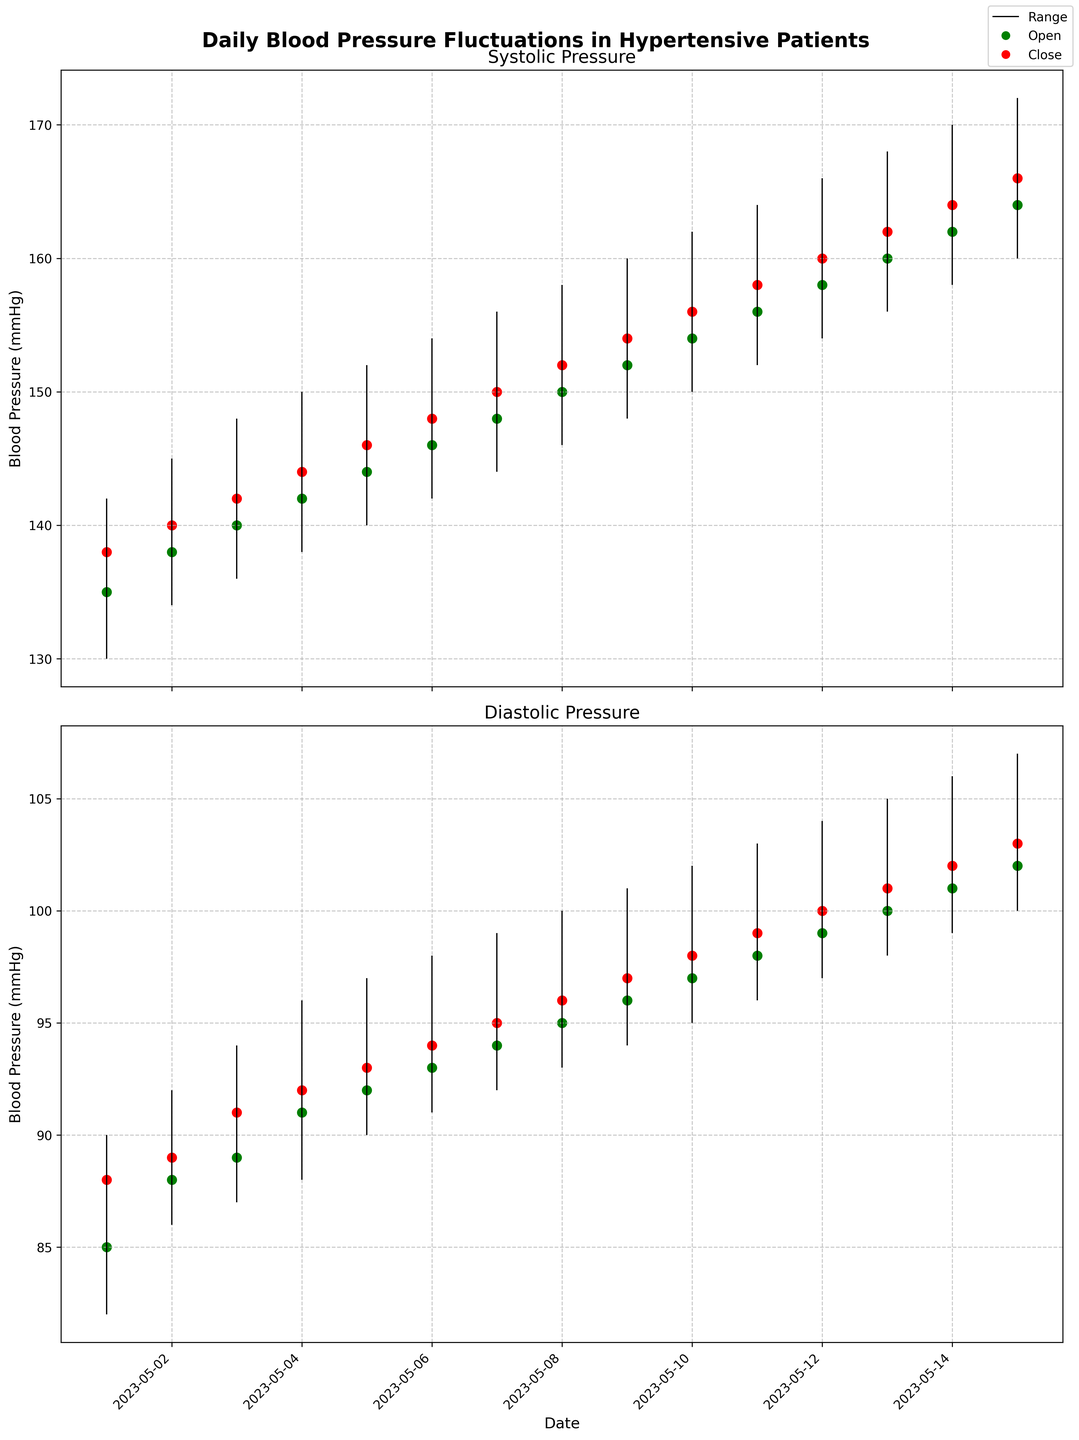What's the title of the figure? The figure has a title at the top. Reading the text displayed, it says "Daily Blood Pressure Fluctuations in Hypertensive Patients".
Answer: Daily Blood Pressure Fluctuations in Hypertensive Patients How are the systolic and diastolic pressures visually distinguished? In the figure, the systolic and diastolic pressures are shown in separate subplots. The systolic pressure is in the top plot, while the diastolic pressure is in the bottom plot.
Answer: Separate subplots Which color represents the 'Open' blood pressure values in the plot? The green color is used to represent 'Open' blood pressure values, indicated by the green markers on both systolic and diastolic subplots.
Answer: Green On May 1, is the closing systolic blood pressure higher than the opening systolic blood pressure? On May 1, the 'Open' systolic pressure is 135 mmHg, and the 'Close' systolic pressure is 138 mmHg. Since 138 is greater than 135, the closing pressure is higher.
Answer: Yes How many days show a higher 'High' systolic pressure than 160 mmHg? The dates and corresponding high systolic pressures are examined. The dates with high pressures above 160 mmHg are May 10 (162), May 11 (164), May 12 (166), May 13 (168), May 14 (170), May 15 (172). Therefore, it's six days.
Answer: 6 What is the average closing diastolic pressure for the first 5 days? The closing diastolic pressures for the first 5 days are 88, 89, 91, 92, and 93 mmHg. Summing these values gives 88 + 89 + 91 + 92 + 93 = 453. Dividing by 5 (the number of days) gives 453 / 5 = 90.6.
Answer: 90.6 mmHg What was the difference between the highest and lowest systolic pressure on May 4? On May 4, the highest systolic pressure is 150 mmHg and the lowest is 138 mmHg. The difference is calculated as 150 - 138 = 12.
Answer: 12 mmHg Which day's high systolic pressure exceeds all previous days' highs? Analyzing the high systolic pressure for each day, the first day with a high systolic pressure that exceeds all previous values is May 11 with a high systolic pressure of 164 mmHg.
Answer: May 11 Which day shows the smallest range in diastolic pressures? To find the smallest range in diastolic pressure, examine the difference between the 'High' and 'Low' values. The smallest difference is 4 mmHg on May 2 (High: 92, Low: 86), giving a range of 92 - 86 = 6.
Answer: May 2 